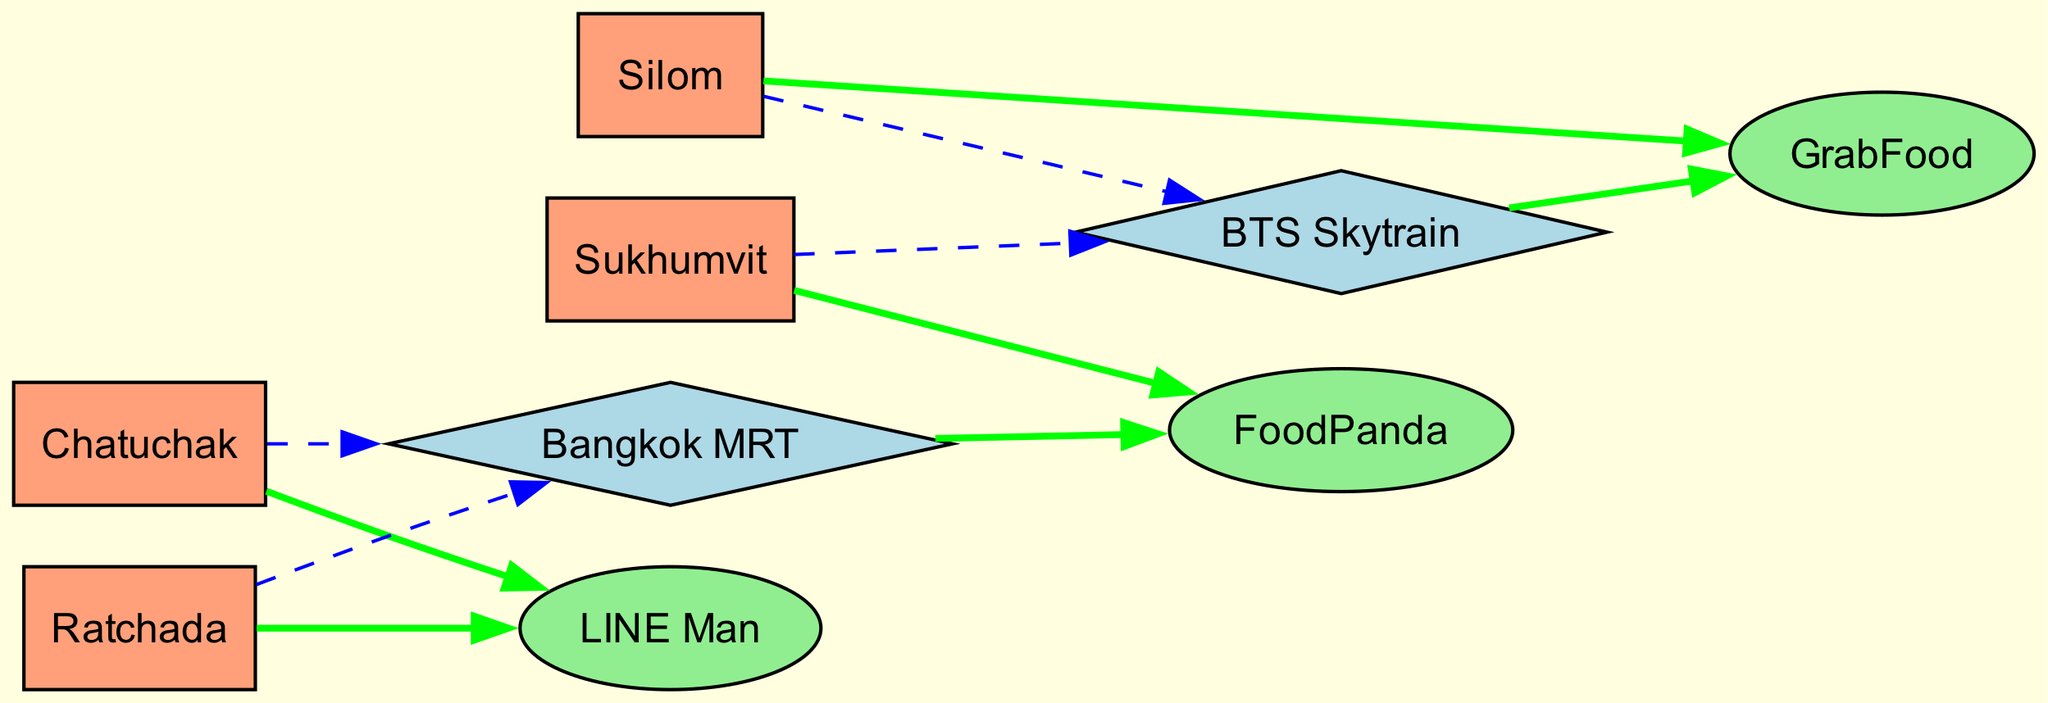What are the food delivery options connected to Sukhumvit? According to the diagram, Sukhumvit directly connects to FoodPanda and the BTS Skytrain, showing that both options are available there.
Answer: FoodPanda, BTS Skytrain Which popular transportation route is connected to Chatuchak? The diagram indicates that Chatuchak is connected to the Bangkok MRT, enhancing access to the area.
Answer: Bangkok MRT How many nodes are there in the diagram? By counting the nodes listed in the data, there are a total of 9 nodes represented including locations and food delivery options.
Answer: 9 Which food delivery service is connected to Silom? The diagram shows that Silom has a direct connection to GrabFood, indicating it's one of the delivery services available in that area.
Answer: GrabFood How many edges lead to LINE Man? By examining the diagram, it can be seen that there are two edges leading to LINE Man, one from Chatuchak and another from Ratchada.
Answer: 2 Which transportation service connects to both Sukhumvit and Silom? Looking at the diagram, the BTS Skytrain serves as the connecting transportation service for both Sukhumvit and Silom.
Answer: BTS Skytrain Are there any food delivery options directly connected to Bangkok MRT? Yes, according to the diagram, Bangkok MRT has a direct connection to FoodPanda, demonstrating this option's availability in that area.
Answer: FoodPanda How many total connections (edges) are there in the diagram? By counting the edges listed in the data, the diagram has a total of 10 connections between the nodes.
Answer: 10 Which location is connected to the most food delivery services? Analyzing the diagram, Sukhumvit is connected to FoodPanda while Silom connects to GrabFood and both lines connect to their respective transportation options, showing mixed accessibility. However, since direct connections can vary, each location has unique delivery options.
Answer: Sukhumvit, Silom 